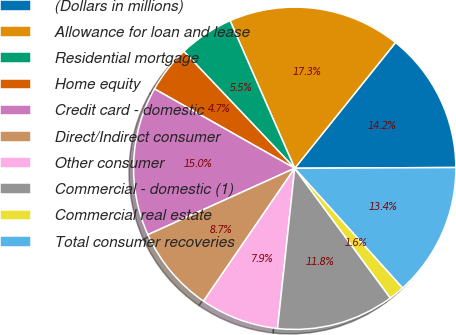Convert chart to OTSL. <chart><loc_0><loc_0><loc_500><loc_500><pie_chart><fcel>(Dollars in millions)<fcel>Allowance for loan and lease<fcel>Residential mortgage<fcel>Home equity<fcel>Credit card - domestic<fcel>Direct/Indirect consumer<fcel>Other consumer<fcel>Commercial - domestic (1)<fcel>Commercial real estate<fcel>Total consumer recoveries<nl><fcel>14.17%<fcel>17.32%<fcel>5.51%<fcel>4.72%<fcel>14.96%<fcel>8.66%<fcel>7.87%<fcel>11.81%<fcel>1.57%<fcel>13.39%<nl></chart> 